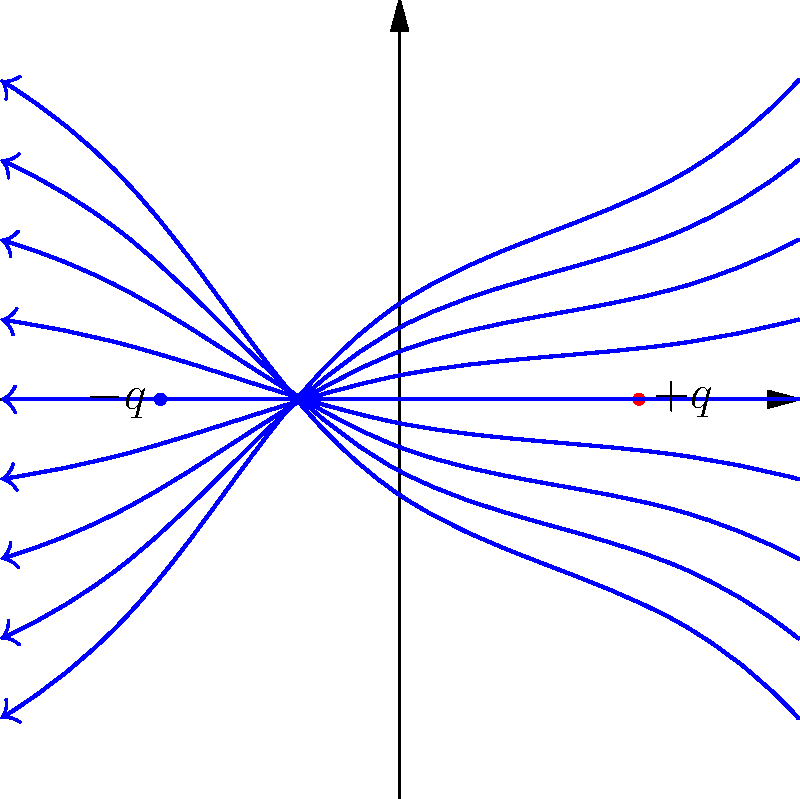As you research depression and medication management to support your child, you come across an analogy comparing the brain's chemical balance to electric fields. To better understand this concept, consider the electric field lines between two charged particles shown in the diagram. What does the direction of the arrows on the field lines indicate about the movement of a positive test charge placed in this field? To understand the direction of electric field lines and their implications:

1. Recall that electric field lines always point from positive to negative charges.

2. In the diagram, we see:
   - A positive charge ($+q$) on the right
   - A negative charge ($-q$) on the left

3. The arrows on the field lines point from the positive charge to the negative charge.

4. The direction of the electric field at any point is tangent to the field line at that point.

5. A positive test charge will experience a force in the same direction as the electric field.

6. Therefore, if a positive test charge were placed in this field, it would:
   - Be repelled by the positive charge on the right
   - Be attracted to the negative charge on the left

7. The motion of the positive test charge would follow the direction of the arrows on the field lines.

This concept is analogous to how neurotransmitters in the brain move between neurons, affecting mood and behavior in depression.
Answer: The arrows indicate the direction a positive test charge would move in the electric field. 